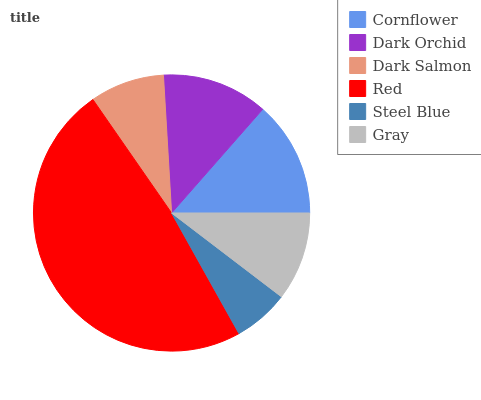Is Steel Blue the minimum?
Answer yes or no. Yes. Is Red the maximum?
Answer yes or no. Yes. Is Dark Orchid the minimum?
Answer yes or no. No. Is Dark Orchid the maximum?
Answer yes or no. No. Is Cornflower greater than Dark Orchid?
Answer yes or no. Yes. Is Dark Orchid less than Cornflower?
Answer yes or no. Yes. Is Dark Orchid greater than Cornflower?
Answer yes or no. No. Is Cornflower less than Dark Orchid?
Answer yes or no. No. Is Dark Orchid the high median?
Answer yes or no. Yes. Is Gray the low median?
Answer yes or no. Yes. Is Cornflower the high median?
Answer yes or no. No. Is Cornflower the low median?
Answer yes or no. No. 